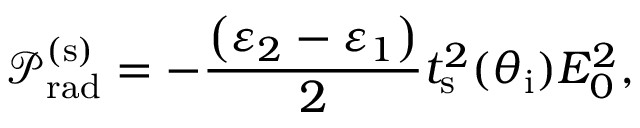Convert formula to latex. <formula><loc_0><loc_0><loc_500><loc_500>\mathcal { P } _ { r a d } ^ { ( s ) } = - \frac { \left ( \varepsilon _ { 2 } - \varepsilon _ { 1 } \right ) } { 2 } t _ { s } ^ { 2 } ( \theta _ { i } ) E _ { 0 } ^ { 2 } ,</formula> 